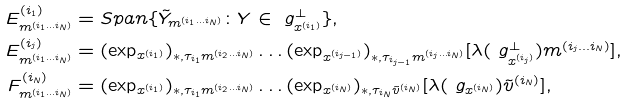<formula> <loc_0><loc_0><loc_500><loc_500>E ^ { ( i _ { 1 } ) } _ { m ^ { ( i _ { 1 } \dots i _ { N } ) } } & = S p a n \{ \tilde { Y } _ { m ^ { ( i _ { 1 } \dots i _ { N } ) } } \colon Y \in \ g _ { x ^ { ( i _ { 1 } ) } } ^ { \perp } \} , \\ E ^ { ( i _ { j } ) } _ { m ^ { ( i _ { 1 } \dots i _ { N } ) } } & = ( \exp _ { x ^ { ( i _ { 1 } ) } } ) _ { \ast , \tau _ { i _ { 1 } } m ^ { ( i _ { 2 } \dots i _ { N } ) } } \dots ( \exp _ { x ^ { ( i _ { j - 1 } ) } } ) _ { \ast , \tau _ { i _ { j - 1 } } m ^ { ( i _ { j } \dots i _ { N } ) } } [ \lambda ( \ g _ { x ^ { ( i _ { j } ) } } ^ { \perp } ) m ^ { ( i _ { j } \dots i _ { N } ) } ] , \\ F ^ { ( i _ { N } ) } _ { m ^ { ( i _ { 1 } \dots i _ { N } ) } } & = ( \exp _ { x ^ { ( i _ { 1 } ) } } ) _ { \ast , \tau _ { i _ { 1 } } m ^ { ( i _ { 2 } \dots i _ { N } ) } } \dots ( \exp _ { x ^ { ( i _ { N } ) } } ) _ { \ast , \tau _ { i _ { N } } \tilde { v } ^ { ( i _ { N } ) } } [ \lambda ( \ g _ { x ^ { ( i _ { N } ) } } ) \tilde { v } ^ { ( i _ { N } ) } ] ,</formula> 